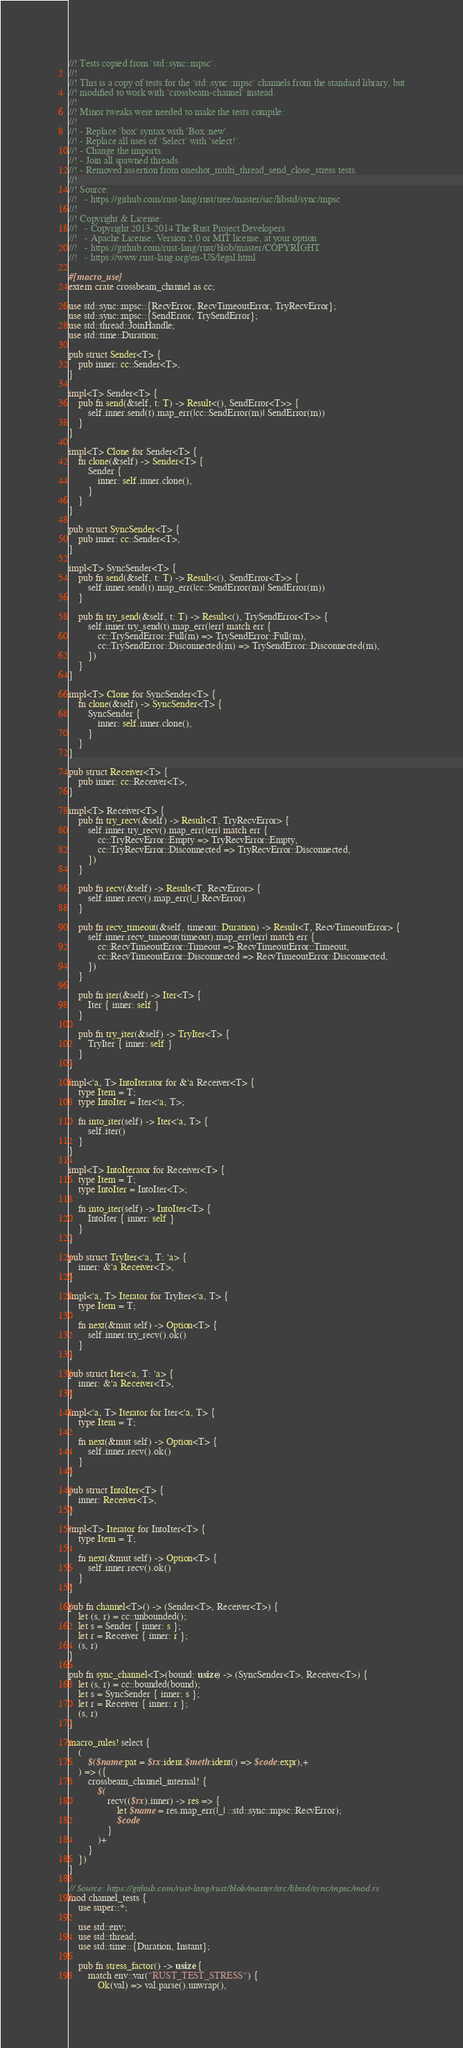<code> <loc_0><loc_0><loc_500><loc_500><_Rust_>//! Tests copied from `std::sync::mpsc`.
//!
//! This is a copy of tests for the `std::sync::mpsc` channels from the standard library, but
//! modified to work with `crossbeam-channel` instead.
//!
//! Minor tweaks were needed to make the tests compile:
//!
//! - Replace `box` syntax with `Box::new`.
//! - Replace all uses of `Select` with `select!`.
//! - Change the imports.
//! - Join all spawned threads.
//! - Removed assertion from oneshot_multi_thread_send_close_stress tests.
//!
//! Source:
//!   - https://github.com/rust-lang/rust/tree/master/src/libstd/sync/mpsc
//!
//! Copyright & License:
//!   - Copyright 2013-2014 The Rust Project Developers
//!   - Apache License, Version 2.0 or MIT license, at your option
//!   - https://github.com/rust-lang/rust/blob/master/COPYRIGHT
//!   - https://www.rust-lang.org/en-US/legal.html

#[macro_use]
extern crate crossbeam_channel as cc;

use std::sync::mpsc::{RecvError, RecvTimeoutError, TryRecvError};
use std::sync::mpsc::{SendError, TrySendError};
use std::thread::JoinHandle;
use std::time::Duration;

pub struct Sender<T> {
    pub inner: cc::Sender<T>,
}

impl<T> Sender<T> {
    pub fn send(&self, t: T) -> Result<(), SendError<T>> {
        self.inner.send(t).map_err(|cc::SendError(m)| SendError(m))
    }
}

impl<T> Clone for Sender<T> {
    fn clone(&self) -> Sender<T> {
        Sender {
            inner: self.inner.clone(),
        }
    }
}

pub struct SyncSender<T> {
    pub inner: cc::Sender<T>,
}

impl<T> SyncSender<T> {
    pub fn send(&self, t: T) -> Result<(), SendError<T>> {
        self.inner.send(t).map_err(|cc::SendError(m)| SendError(m))
    }

    pub fn try_send(&self, t: T) -> Result<(), TrySendError<T>> {
        self.inner.try_send(t).map_err(|err| match err {
            cc::TrySendError::Full(m) => TrySendError::Full(m),
            cc::TrySendError::Disconnected(m) => TrySendError::Disconnected(m),
        })
    }
}

impl<T> Clone for SyncSender<T> {
    fn clone(&self) -> SyncSender<T> {
        SyncSender {
            inner: self.inner.clone(),
        }
    }
}

pub struct Receiver<T> {
    pub inner: cc::Receiver<T>,
}

impl<T> Receiver<T> {
    pub fn try_recv(&self) -> Result<T, TryRecvError> {
        self.inner.try_recv().map_err(|err| match err {
            cc::TryRecvError::Empty => TryRecvError::Empty,
            cc::TryRecvError::Disconnected => TryRecvError::Disconnected,
        })
    }

    pub fn recv(&self) -> Result<T, RecvError> {
        self.inner.recv().map_err(|_| RecvError)
    }

    pub fn recv_timeout(&self, timeout: Duration) -> Result<T, RecvTimeoutError> {
        self.inner.recv_timeout(timeout).map_err(|err| match err {
            cc::RecvTimeoutError::Timeout => RecvTimeoutError::Timeout,
            cc::RecvTimeoutError::Disconnected => RecvTimeoutError::Disconnected,
        })
    }

    pub fn iter(&self) -> Iter<T> {
        Iter { inner: self }
    }

    pub fn try_iter(&self) -> TryIter<T> {
        TryIter { inner: self }
    }
}

impl<'a, T> IntoIterator for &'a Receiver<T> {
    type Item = T;
    type IntoIter = Iter<'a, T>;

    fn into_iter(self) -> Iter<'a, T> {
        self.iter()
    }
}

impl<T> IntoIterator for Receiver<T> {
    type Item = T;
    type IntoIter = IntoIter<T>;

    fn into_iter(self) -> IntoIter<T> {
        IntoIter { inner: self }
    }
}

pub struct TryIter<'a, T: 'a> {
    inner: &'a Receiver<T>,
}

impl<'a, T> Iterator for TryIter<'a, T> {
    type Item = T;

    fn next(&mut self) -> Option<T> {
        self.inner.try_recv().ok()
    }
}

pub struct Iter<'a, T: 'a> {
    inner: &'a Receiver<T>,
}

impl<'a, T> Iterator for Iter<'a, T> {
    type Item = T;

    fn next(&mut self) -> Option<T> {
        self.inner.recv().ok()
    }
}

pub struct IntoIter<T> {
    inner: Receiver<T>,
}

impl<T> Iterator for IntoIter<T> {
    type Item = T;

    fn next(&mut self) -> Option<T> {
        self.inner.recv().ok()
    }
}

pub fn channel<T>() -> (Sender<T>, Receiver<T>) {
    let (s, r) = cc::unbounded();
    let s = Sender { inner: s };
    let r = Receiver { inner: r };
    (s, r)
}

pub fn sync_channel<T>(bound: usize) -> (SyncSender<T>, Receiver<T>) {
    let (s, r) = cc::bounded(bound);
    let s = SyncSender { inner: s };
    let r = Receiver { inner: r };
    (s, r)
}

macro_rules! select {
    (
        $($name:pat = $rx:ident.$meth:ident() => $code:expr),+
    ) => ({
        crossbeam_channel_internal! {
            $(
                recv(($rx).inner) -> res => {
                    let $name = res.map_err(|_| ::std::sync::mpsc::RecvError);
                    $code
                }
            )+
        }
    })
}

// Source: https://github.com/rust-lang/rust/blob/master/src/libstd/sync/mpsc/mod.rs
mod channel_tests {
    use super::*;

    use std::env;
    use std::thread;
    use std::time::{Duration, Instant};

    pub fn stress_factor() -> usize {
        match env::var("RUST_TEST_STRESS") {
            Ok(val) => val.parse().unwrap(),</code> 